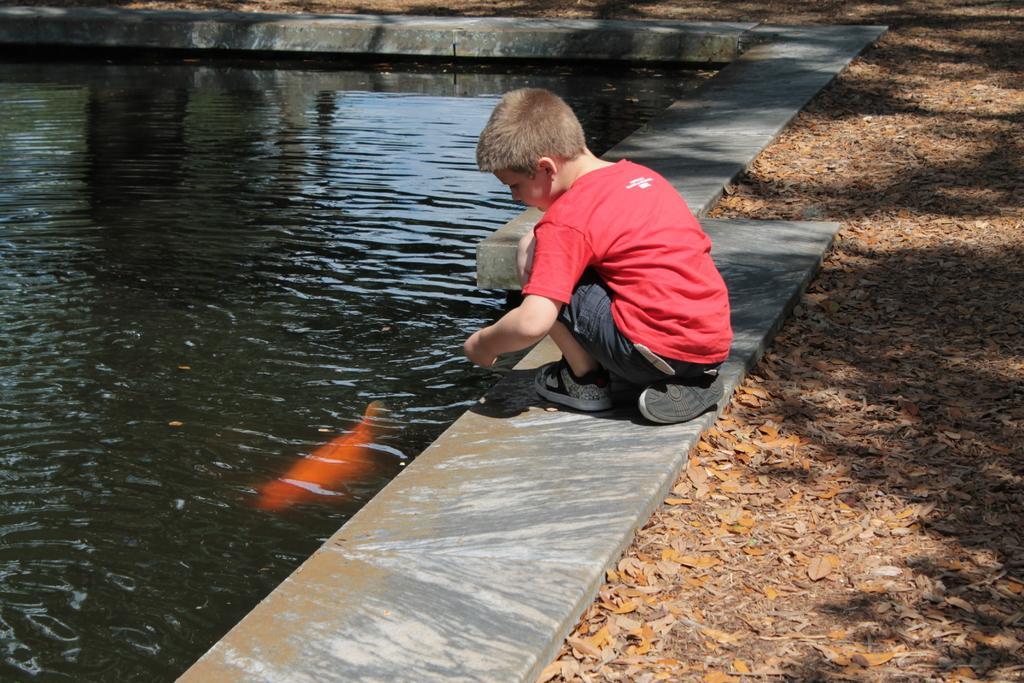Who is the main subject in the image? There is a boy in the image. Where is the boy located in the image? The boy is standing in front of a pond. What can be seen inside the pond? There is a fish inside the pond. What type of plastic item can be seen in the alley behind the boy? There is no alley or plastic item present in the image; it features a boy standing in front of a pond with a fish inside. 